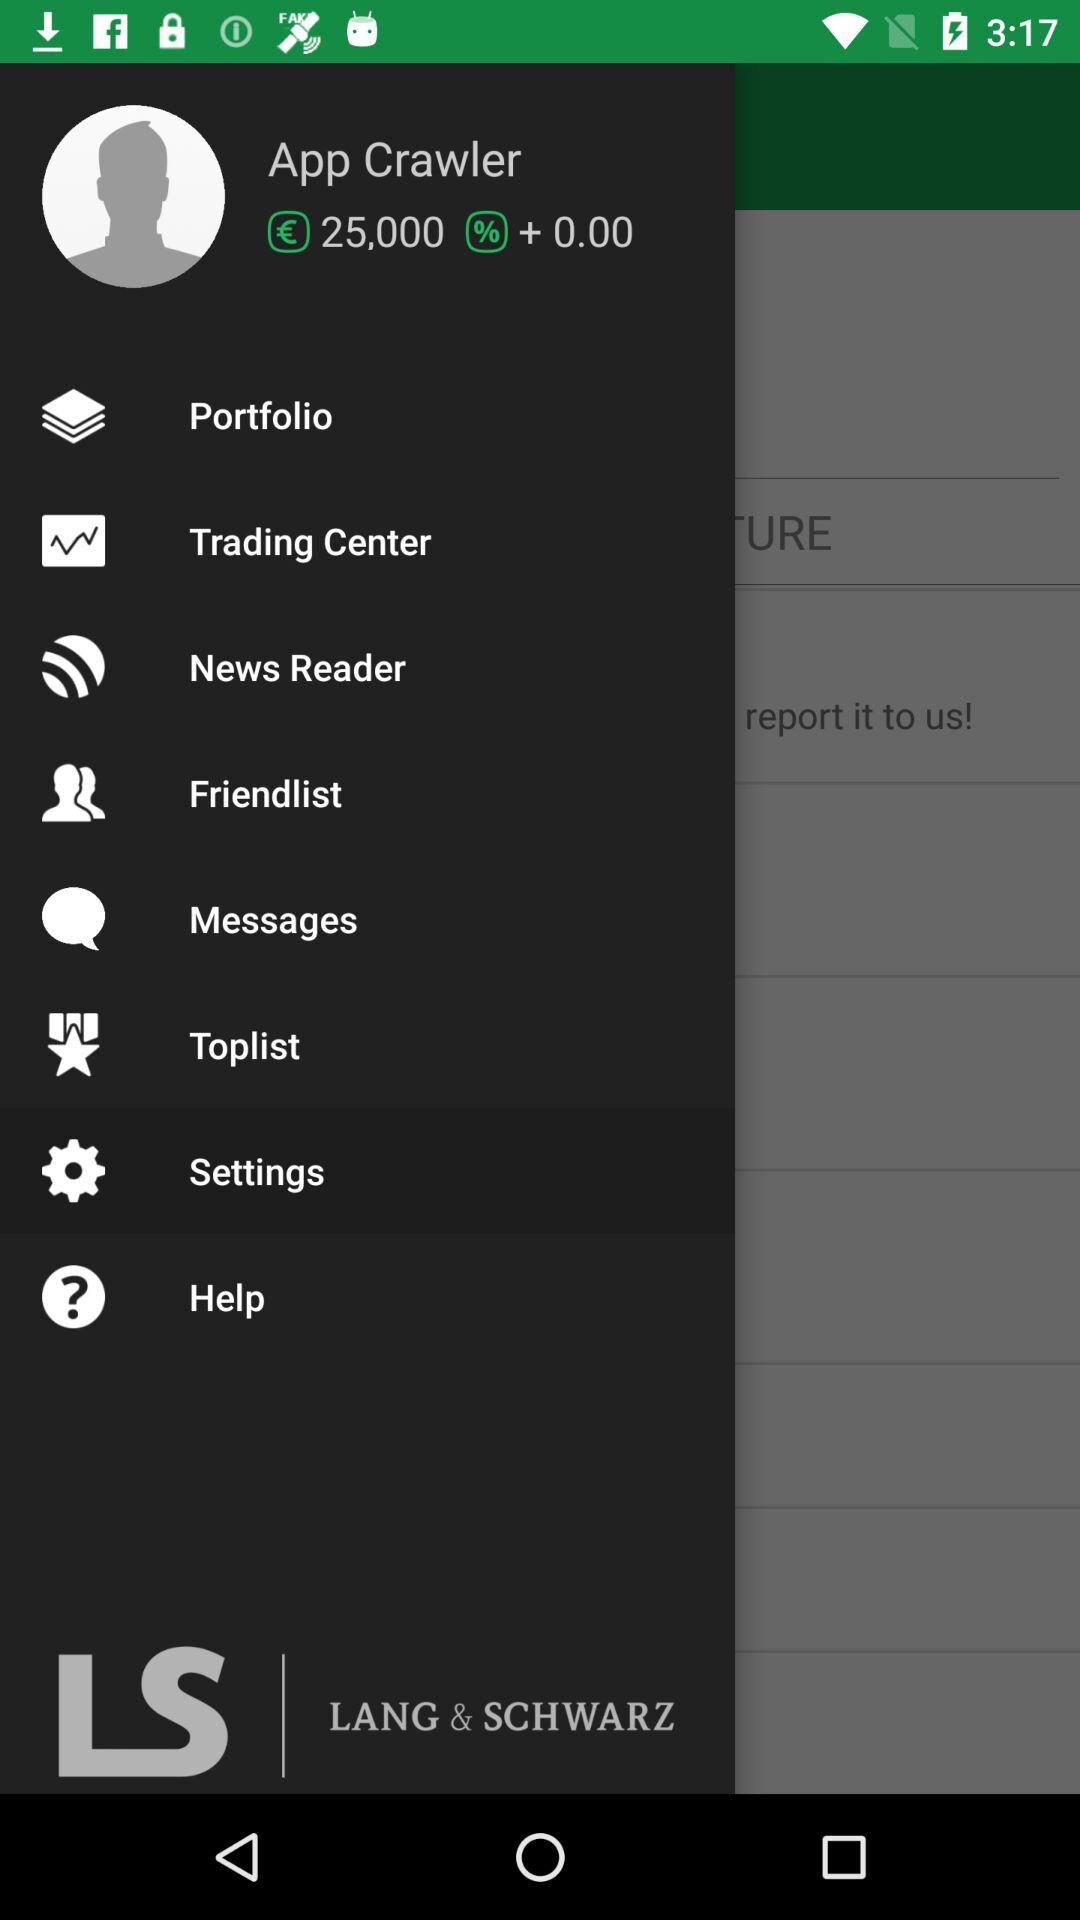What is the user name? The user name is App Crawler. 